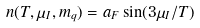<formula> <loc_0><loc_0><loc_500><loc_500>n ( T , \mu _ { I } , m _ { q } ) = a _ { F } \sin ( 3 \mu _ { I } / T )</formula> 